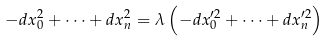Convert formula to latex. <formula><loc_0><loc_0><loc_500><loc_500>- d x _ { 0 } ^ { 2 } + \dots + d x _ { n } ^ { 2 } = \lambda \left ( - d x _ { 0 } ^ { \prime 2 } + \dots + d x _ { n } ^ { \prime 2 } \right )</formula> 